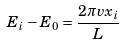<formula> <loc_0><loc_0><loc_500><loc_500>E _ { i } - E _ { 0 } = \frac { 2 \pi v x _ { i } } { L }</formula> 